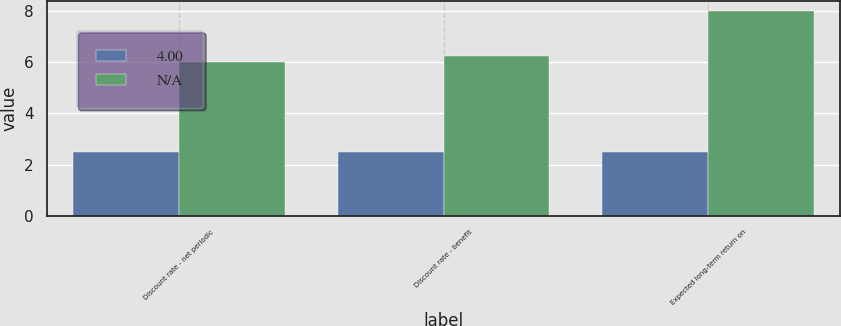<chart> <loc_0><loc_0><loc_500><loc_500><stacked_bar_chart><ecel><fcel>Discount rate - net periodic<fcel>Discount rate - benefit<fcel>Expected long-term return on<nl><fcel>4<fcel>2.5<fcel>2.5<fcel>2.5<nl><fcel>nan<fcel>6<fcel>6.25<fcel>8<nl></chart> 